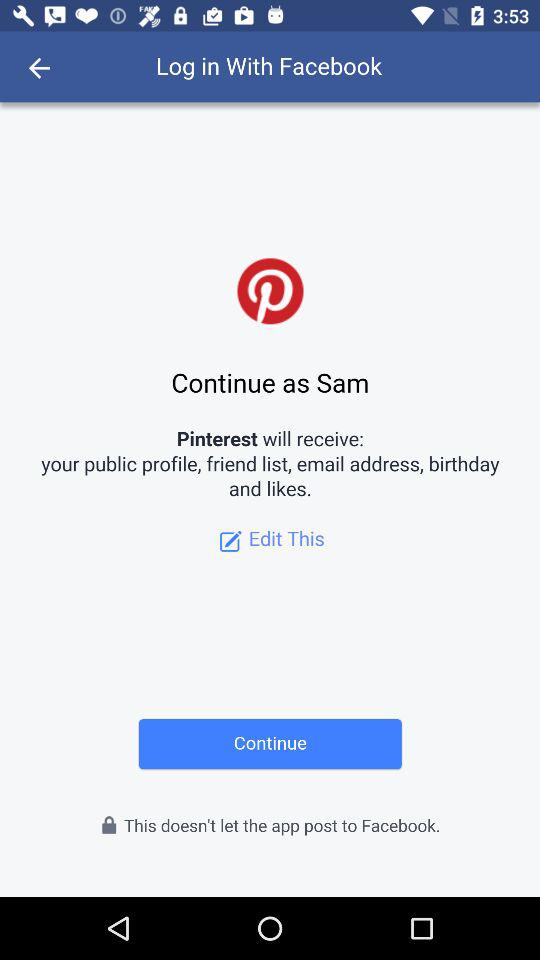What is the user name with which the user can continue to the profile? The user name is Sam. 